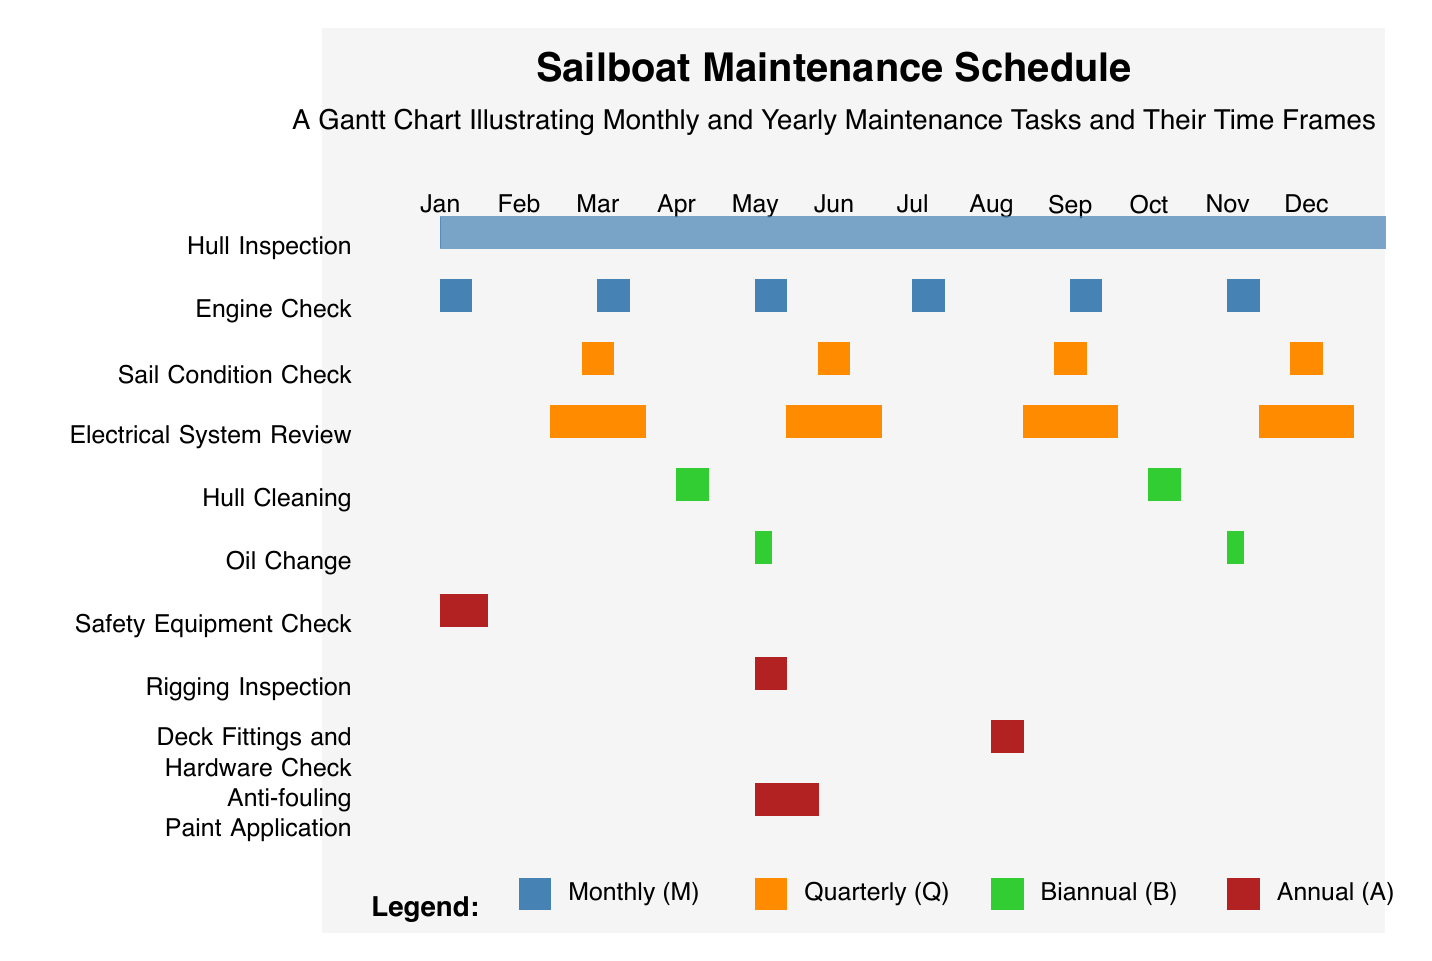What maintenance task occurs monthly starting in January? The diagram shows that "Hull Cleaning" is represented by a filled bar starting from January and continuing through the months, indicating its monthly frequency.
Answer: Hull Cleaning How often is the "Oil Change" scheduled? The Gantt chart displays "Oil Change" with bars in several months, indicating it occurs monthly throughout the year.
Answer: Monthly Which maintenance task is checked biannually? By looking at the specific bars, "Rigging Inspection" has filled bars occurring in two separate months that represent biannual frequency.
Answer: Rigging Inspection In which month does the "Annual" electrical system review occur? The chart shows that "Electrical System Review" has a filled bar indicating it occurs once a year in July, marked clearly on the diagram.
Answer: July How many tasks are scheduled quarterly? Upon reviewing the diagram, there are three tasks, as indicated by the quarterly colored bars that appear four times in the year.
Answer: Three Which task occurs in both April and September? The "Safety Equipment Check" has bars that extend and highlight both April and September, indicating it is performed during those months.
Answer: Safety Equipment Check What color represents monthly tasks in the Gantt chart? The diagram visually indicates that monthly tasks are represented in a specific shade of blue, making it easy to distinguish from other task frequencies.
Answer: Blue Which task is scheduled for both January and October? In reviewing the bars, "Hull Inspection" is scheduled in both January and October, indicating its regular frequency across the year.
Answer: Hull Inspection What is the total number of maintenance tasks listed? The diagram outlines a total of ten distinct maintenance tasks, all listed in the left column.
Answer: Ten 